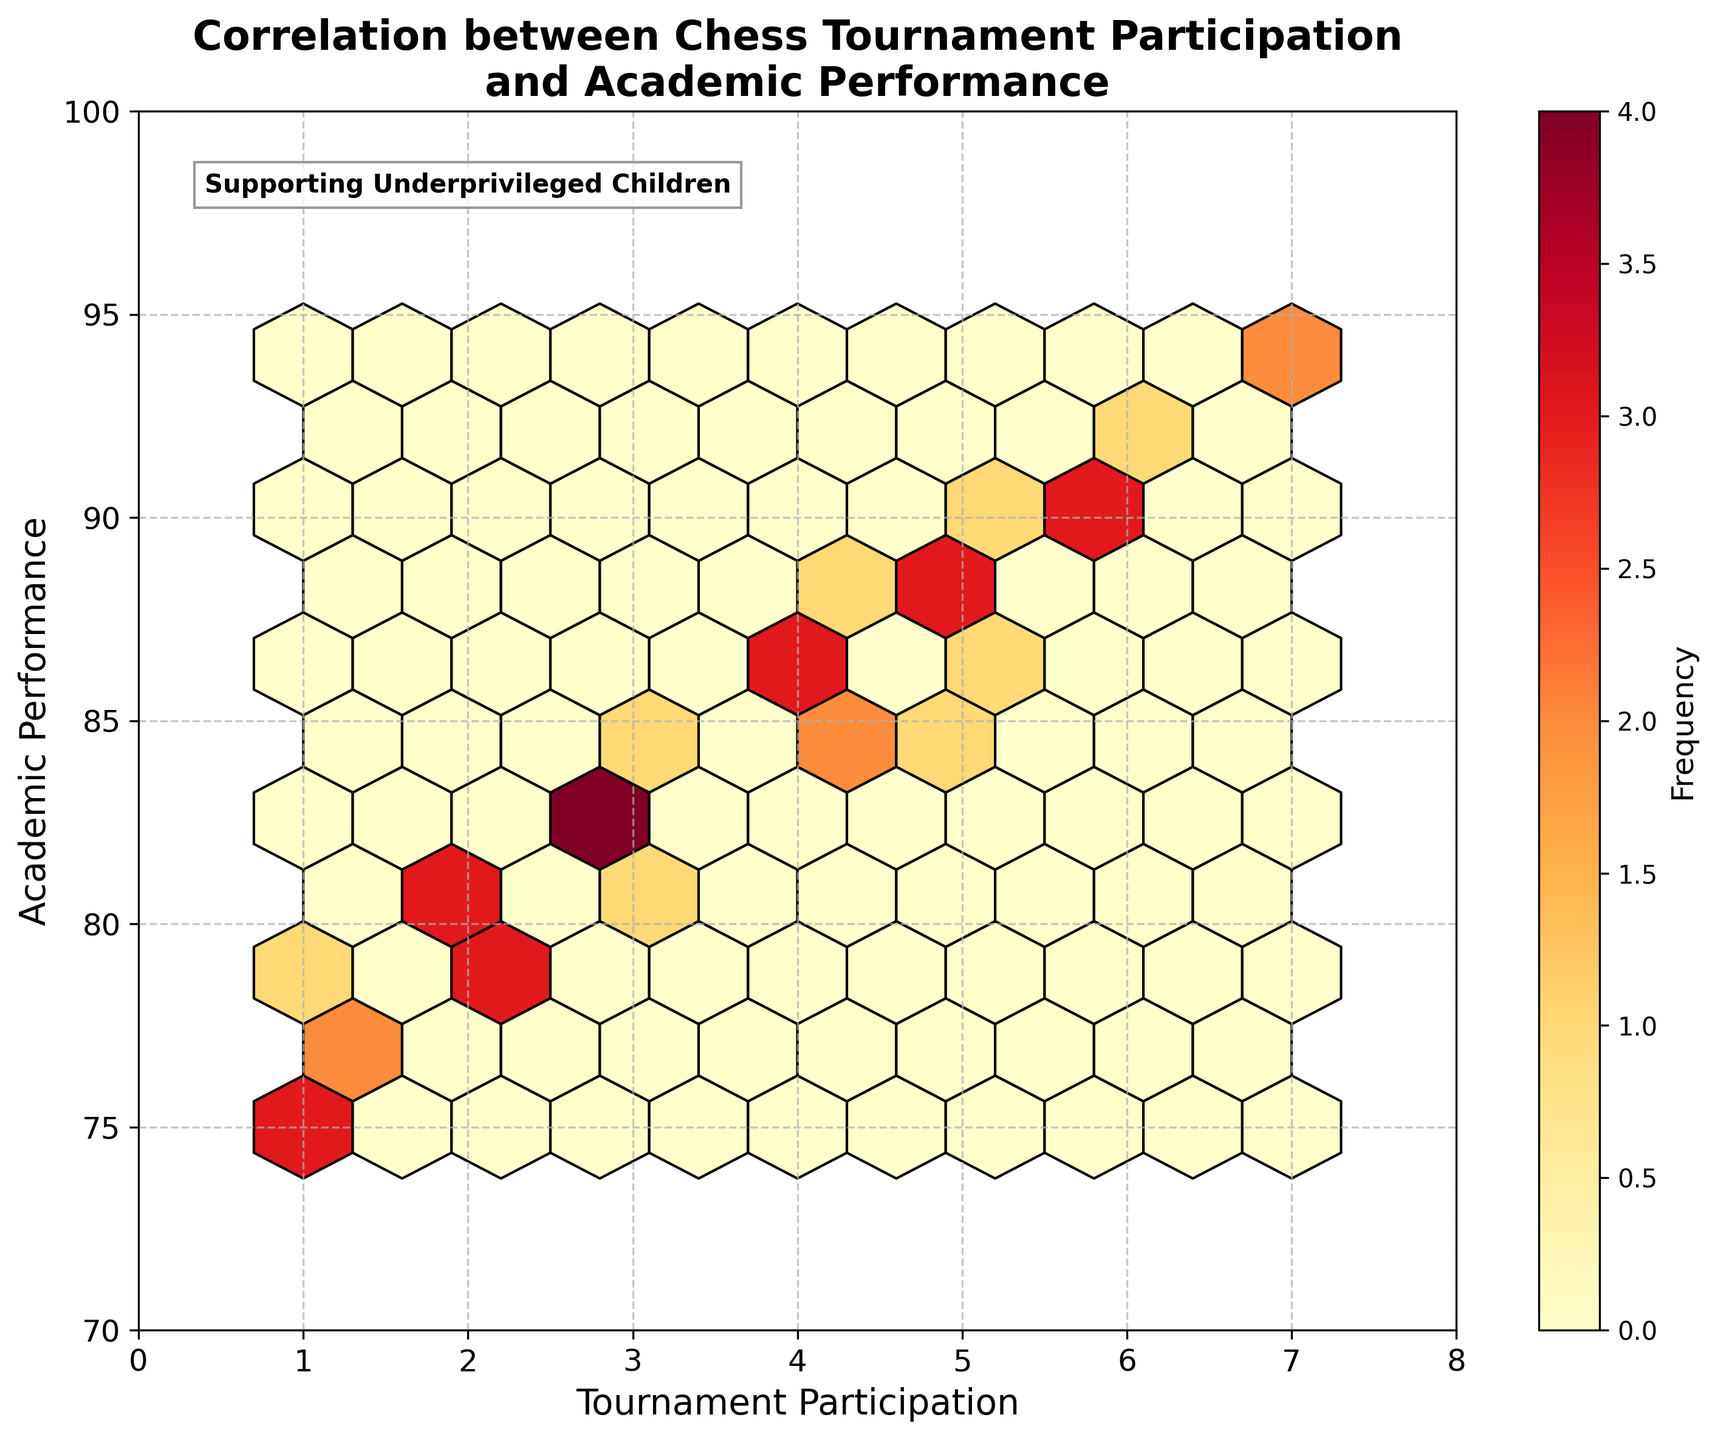What is the title of the plot? The title of the plot is located at the top and reads "Correlation between Chess Tournament Participation and Academic Performance."
Answer: Correlation between Chess Tournament Participation and Academic Performance What are the x-axis and y-axis labels? The x-axis label is "Tournament Participation," and the y-axis label is "Academic Performance." These labels help in identifying what each axis represents.
Answer: Tournament Participation, Academic Performance What does the color intensity in the hexbin plot represent? The color intensity in the hexbin plot represents the frequency of data points within each hexagonal bin. Darker colors indicate a higher frequency of points.
Answer: Frequency What is the general trend observed between tournament participation and academic performance? Observing the plot, as tournament participation increases, academic performance also tends to increase, indicating a positive correlation between the two variables.
Answer: Positive correlation What is the academic performance range for children who participated in 4 tournaments? By looking at the hexbin plot, the academic performance for children who participated in 4 tournaments ranges approximately from 84 to 88.
Answer: 84 to 88 How many bins appear to have the highest frequency on the plot, and where are they located? By examining the plot's color intensity, there are a few bins with the highest frequency which appear darker, generally located in the region where tournament participation is between 2 to 5, and academic performance is between 80 to 90.
Answer: 2-5 tournaments, 80-90 academic performance Are there any outliers visible in the plot? By checking the distribution of the hexagonal bins, there do not appear to be any significant outliers since all points seem to contribute to the overall trend and are clustered together.
Answer: No significant outliers Comparing children who participated in 1 tournament versus those who participated in 7 tournaments, which group shows a higher academic performance? By comparing the group locations, the children who participated in 7 tournaments show higher academic performance, with scores around 93-94, whereas those in 1 tournament have scores around 75-78.
Answer: Participated in 7 tournaments What is the approximate average academic performance for children who participated in tournaments? From the hexbin plot, the data points are mostly clustered in higher ranges. A rough estimate of the average academic performance can be around 83 to 88.
Answer: 83 to 88 What does the color bar attached to the plot represent? The color bar on the side of the plot indicates the frequency scale, helping to identify how many data points fall into each hexagonal bin based on the color intensity.
Answer: Frequency scale 